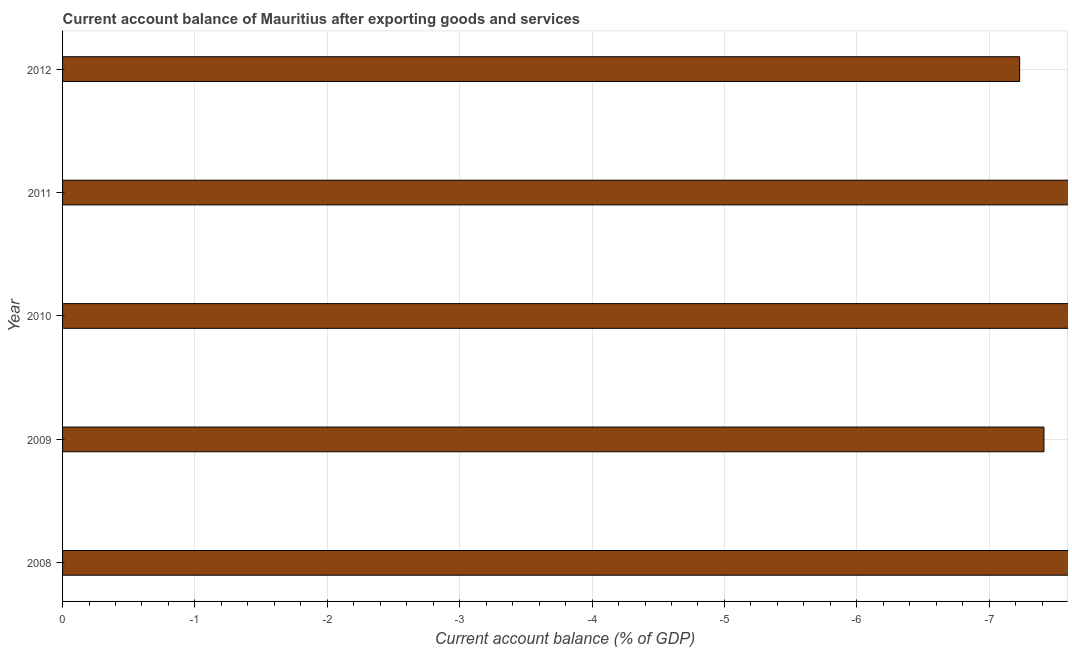Does the graph contain any zero values?
Ensure brevity in your answer.  Yes. Does the graph contain grids?
Your answer should be very brief. Yes. What is the title of the graph?
Give a very brief answer. Current account balance of Mauritius after exporting goods and services. What is the label or title of the X-axis?
Give a very brief answer. Current account balance (% of GDP). What is the label or title of the Y-axis?
Keep it short and to the point. Year. Across all years, what is the minimum current account balance?
Your answer should be very brief. 0. What is the average current account balance per year?
Your answer should be compact. 0. In how many years, is the current account balance greater than -3.8 %?
Your answer should be very brief. 0. How many years are there in the graph?
Provide a succinct answer. 5. What is the difference between two consecutive major ticks on the X-axis?
Provide a succinct answer. 1. What is the Current account balance (% of GDP) in 2009?
Ensure brevity in your answer.  0. What is the Current account balance (% of GDP) of 2010?
Offer a terse response. 0. What is the Current account balance (% of GDP) of 2011?
Make the answer very short. 0. What is the Current account balance (% of GDP) of 2012?
Your answer should be compact. 0. 